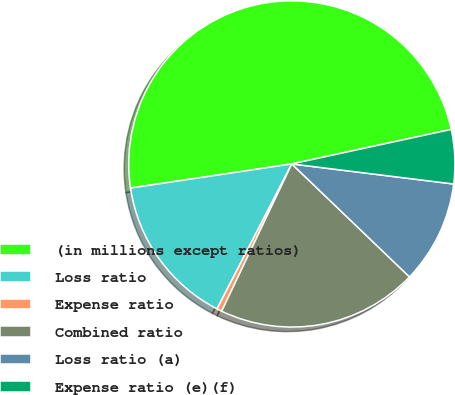<chart> <loc_0><loc_0><loc_500><loc_500><pie_chart><fcel>(in millions except ratios)<fcel>Loss ratio<fcel>Expense ratio<fcel>Combined ratio<fcel>Loss ratio (a)<fcel>Expense ratio (e)(f)<nl><fcel>48.97%<fcel>15.05%<fcel>0.51%<fcel>19.9%<fcel>10.21%<fcel>5.36%<nl></chart> 